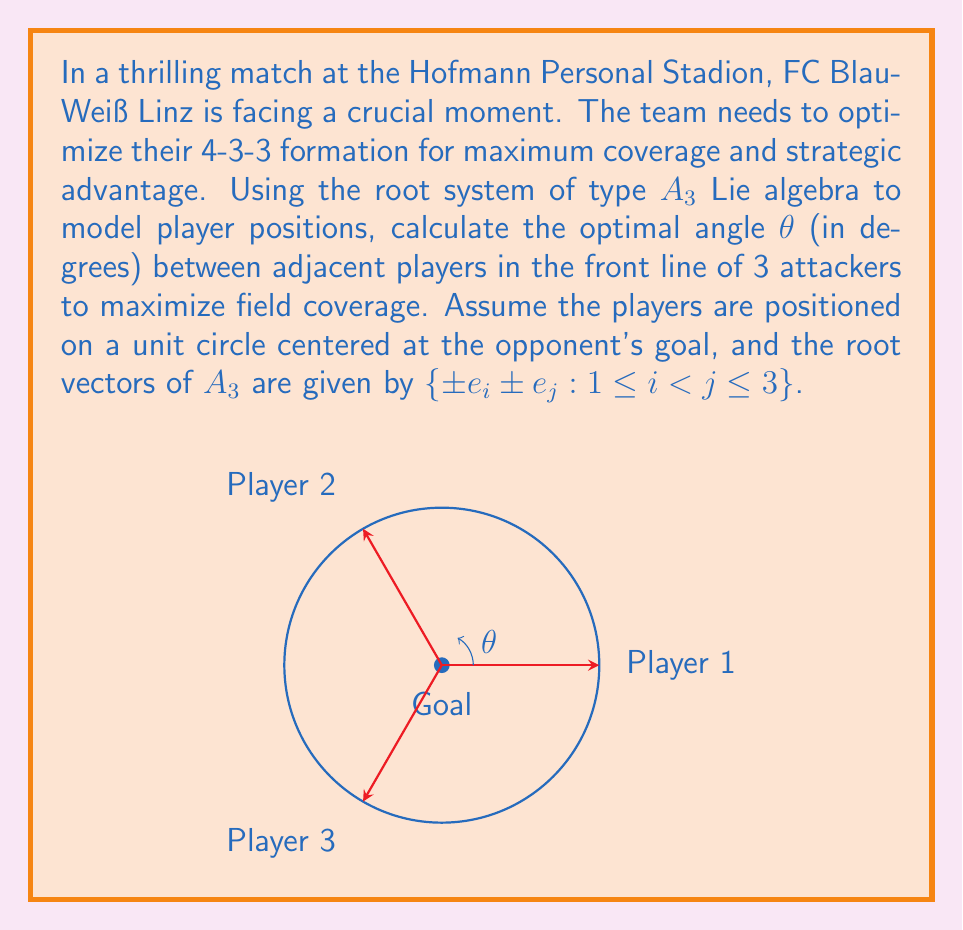Provide a solution to this math problem. Let's approach this step-by-step:

1) The root system of type $A_3$ Lie algebra has 6 positive roots:
   $\{e_1 - e_2, e_1 - e_3, e_2 - e_3, e_1 + e_2, e_1 + e_3, e_2 + e_3\}$

2) In our football context, we're interested in the angles between these root vectors, as they represent the optimal angles between players.

3) The angle between two root vectors $\alpha$ and $\beta$ is given by the formula:
   $$\cos \theta = \frac{2(\alpha, \beta)}{(\alpha, \alpha)(\beta, \beta)}$$
   where $(\alpha, \beta)$ is the inner product of $\alpha$ and $\beta$.

4) For $A_3$, all roots have the same length, so $(\alpha, \alpha) = (\beta, \beta) = 2$.

5) The inner product $(\alpha, \beta)$ for adjacent roots in $A_3$ is always 1.

6) Substituting these values:
   $$\cos \theta = \frac{2(1)}{(2)(2)} = \frac{1}{2}$$

7) Taking the inverse cosine:
   $$\theta = \arccos(\frac{1}{2})$$

8) Converting to degrees:
   $$\theta = \arccos(\frac{1}{2}) \cdot \frac{180}{\pi} \approx 60^\circ$$

This angle of 60° between adjacent players in the front line optimizes their coverage based on the $A_3$ root system.
Answer: 60° 